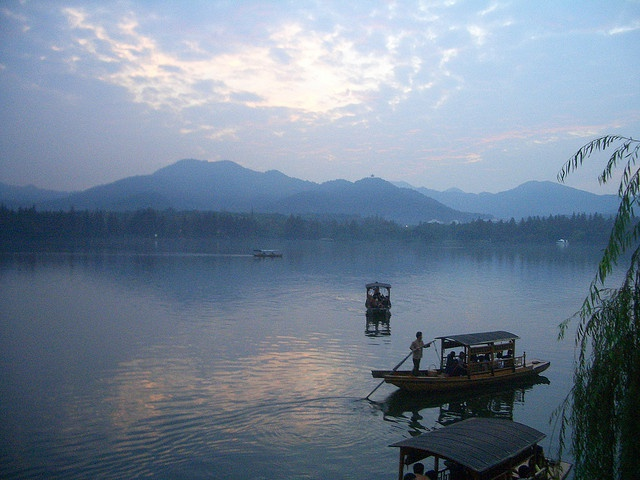Describe the objects in this image and their specific colors. I can see boat in gray, black, purple, and blue tones, boat in gray, black, and navy tones, boat in gray and black tones, people in gray, black, and purple tones, and people in gray, black, blue, and navy tones in this image. 